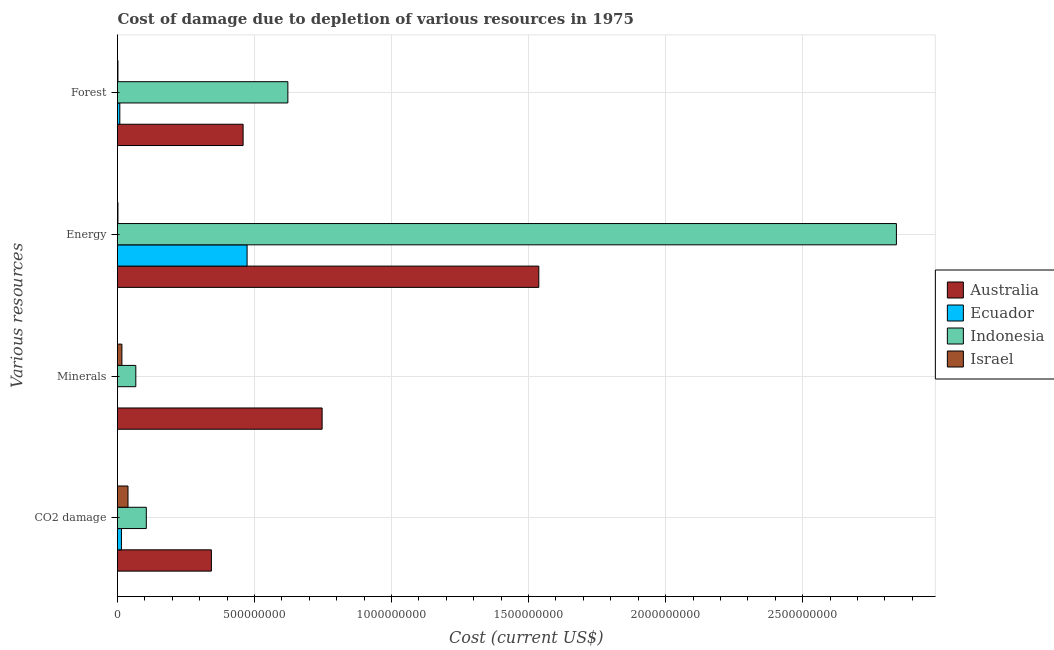How many groups of bars are there?
Give a very brief answer. 4. Are the number of bars per tick equal to the number of legend labels?
Your answer should be compact. Yes. What is the label of the 1st group of bars from the top?
Provide a succinct answer. Forest. What is the cost of damage due to depletion of forests in Australia?
Ensure brevity in your answer.  4.58e+08. Across all countries, what is the maximum cost of damage due to depletion of energy?
Your answer should be compact. 2.84e+09. Across all countries, what is the minimum cost of damage due to depletion of forests?
Make the answer very short. 1.56e+06. In which country was the cost of damage due to depletion of energy minimum?
Keep it short and to the point. Israel. What is the total cost of damage due to depletion of minerals in the graph?
Offer a terse response. 8.29e+08. What is the difference between the cost of damage due to depletion of energy in Indonesia and that in Ecuador?
Give a very brief answer. 2.37e+09. What is the difference between the cost of damage due to depletion of forests in Israel and the cost of damage due to depletion of coal in Ecuador?
Keep it short and to the point. -1.28e+07. What is the average cost of damage due to depletion of minerals per country?
Provide a short and direct response. 2.07e+08. What is the difference between the cost of damage due to depletion of minerals and cost of damage due to depletion of forests in Israel?
Your answer should be very brief. 1.45e+07. What is the ratio of the cost of damage due to depletion of energy in Ecuador to that in Indonesia?
Provide a short and direct response. 0.17. Is the difference between the cost of damage due to depletion of forests in Israel and Indonesia greater than the difference between the cost of damage due to depletion of minerals in Israel and Indonesia?
Provide a succinct answer. No. What is the difference between the highest and the second highest cost of damage due to depletion of minerals?
Your response must be concise. 6.80e+08. What is the difference between the highest and the lowest cost of damage due to depletion of energy?
Make the answer very short. 2.84e+09. What does the 2nd bar from the bottom in Minerals represents?
Give a very brief answer. Ecuador. Is it the case that in every country, the sum of the cost of damage due to depletion of coal and cost of damage due to depletion of minerals is greater than the cost of damage due to depletion of energy?
Your response must be concise. No. How many bars are there?
Make the answer very short. 16. How many countries are there in the graph?
Provide a succinct answer. 4. Where does the legend appear in the graph?
Your answer should be compact. Center right. What is the title of the graph?
Your answer should be compact. Cost of damage due to depletion of various resources in 1975 . Does "Canada" appear as one of the legend labels in the graph?
Make the answer very short. No. What is the label or title of the X-axis?
Your answer should be compact. Cost (current US$). What is the label or title of the Y-axis?
Ensure brevity in your answer.  Various resources. What is the Cost (current US$) in Australia in CO2 damage?
Give a very brief answer. 3.43e+08. What is the Cost (current US$) in Ecuador in CO2 damage?
Make the answer very short. 1.43e+07. What is the Cost (current US$) in Indonesia in CO2 damage?
Make the answer very short. 1.05e+08. What is the Cost (current US$) in Israel in CO2 damage?
Offer a very short reply. 3.83e+07. What is the Cost (current US$) in Australia in Minerals?
Ensure brevity in your answer.  7.47e+08. What is the Cost (current US$) in Ecuador in Minerals?
Offer a very short reply. 4.07e+04. What is the Cost (current US$) of Indonesia in Minerals?
Your response must be concise. 6.68e+07. What is the Cost (current US$) of Israel in Minerals?
Offer a very short reply. 1.60e+07. What is the Cost (current US$) in Australia in Energy?
Keep it short and to the point. 1.54e+09. What is the Cost (current US$) in Ecuador in Energy?
Ensure brevity in your answer.  4.73e+08. What is the Cost (current US$) in Indonesia in Energy?
Provide a succinct answer. 2.84e+09. What is the Cost (current US$) in Israel in Energy?
Keep it short and to the point. 1.55e+06. What is the Cost (current US$) of Australia in Forest?
Your answer should be compact. 4.58e+08. What is the Cost (current US$) in Ecuador in Forest?
Offer a terse response. 8.42e+06. What is the Cost (current US$) of Indonesia in Forest?
Keep it short and to the point. 6.22e+08. What is the Cost (current US$) in Israel in Forest?
Give a very brief answer. 1.56e+06. Across all Various resources, what is the maximum Cost (current US$) in Australia?
Give a very brief answer. 1.54e+09. Across all Various resources, what is the maximum Cost (current US$) in Ecuador?
Provide a succinct answer. 4.73e+08. Across all Various resources, what is the maximum Cost (current US$) in Indonesia?
Your response must be concise. 2.84e+09. Across all Various resources, what is the maximum Cost (current US$) in Israel?
Your answer should be compact. 3.83e+07. Across all Various resources, what is the minimum Cost (current US$) of Australia?
Your answer should be compact. 3.43e+08. Across all Various resources, what is the minimum Cost (current US$) of Ecuador?
Make the answer very short. 4.07e+04. Across all Various resources, what is the minimum Cost (current US$) in Indonesia?
Provide a succinct answer. 6.68e+07. Across all Various resources, what is the minimum Cost (current US$) in Israel?
Your response must be concise. 1.55e+06. What is the total Cost (current US$) in Australia in the graph?
Your answer should be compact. 3.08e+09. What is the total Cost (current US$) of Ecuador in the graph?
Offer a very short reply. 4.96e+08. What is the total Cost (current US$) in Indonesia in the graph?
Make the answer very short. 3.64e+09. What is the total Cost (current US$) in Israel in the graph?
Provide a short and direct response. 5.74e+07. What is the difference between the Cost (current US$) in Australia in CO2 damage and that in Minerals?
Provide a succinct answer. -4.04e+08. What is the difference between the Cost (current US$) in Ecuador in CO2 damage and that in Minerals?
Give a very brief answer. 1.43e+07. What is the difference between the Cost (current US$) in Indonesia in CO2 damage and that in Minerals?
Provide a short and direct response. 3.83e+07. What is the difference between the Cost (current US$) of Israel in CO2 damage and that in Minerals?
Keep it short and to the point. 2.22e+07. What is the difference between the Cost (current US$) in Australia in CO2 damage and that in Energy?
Give a very brief answer. -1.19e+09. What is the difference between the Cost (current US$) of Ecuador in CO2 damage and that in Energy?
Your answer should be compact. -4.59e+08. What is the difference between the Cost (current US$) in Indonesia in CO2 damage and that in Energy?
Provide a short and direct response. -2.74e+09. What is the difference between the Cost (current US$) in Israel in CO2 damage and that in Energy?
Offer a terse response. 3.67e+07. What is the difference between the Cost (current US$) of Australia in CO2 damage and that in Forest?
Your answer should be very brief. -1.16e+08. What is the difference between the Cost (current US$) of Ecuador in CO2 damage and that in Forest?
Keep it short and to the point. 5.93e+06. What is the difference between the Cost (current US$) of Indonesia in CO2 damage and that in Forest?
Ensure brevity in your answer.  -5.16e+08. What is the difference between the Cost (current US$) of Israel in CO2 damage and that in Forest?
Give a very brief answer. 3.67e+07. What is the difference between the Cost (current US$) of Australia in Minerals and that in Energy?
Ensure brevity in your answer.  -7.91e+08. What is the difference between the Cost (current US$) in Ecuador in Minerals and that in Energy?
Offer a very short reply. -4.73e+08. What is the difference between the Cost (current US$) in Indonesia in Minerals and that in Energy?
Ensure brevity in your answer.  -2.78e+09. What is the difference between the Cost (current US$) of Israel in Minerals and that in Energy?
Ensure brevity in your answer.  1.45e+07. What is the difference between the Cost (current US$) of Australia in Minerals and that in Forest?
Ensure brevity in your answer.  2.88e+08. What is the difference between the Cost (current US$) in Ecuador in Minerals and that in Forest?
Your response must be concise. -8.38e+06. What is the difference between the Cost (current US$) in Indonesia in Minerals and that in Forest?
Make the answer very short. -5.55e+08. What is the difference between the Cost (current US$) of Israel in Minerals and that in Forest?
Your answer should be very brief. 1.45e+07. What is the difference between the Cost (current US$) in Australia in Energy and that in Forest?
Provide a short and direct response. 1.08e+09. What is the difference between the Cost (current US$) of Ecuador in Energy and that in Forest?
Keep it short and to the point. 4.64e+08. What is the difference between the Cost (current US$) of Indonesia in Energy and that in Forest?
Give a very brief answer. 2.22e+09. What is the difference between the Cost (current US$) in Israel in Energy and that in Forest?
Your response must be concise. -1.17e+04. What is the difference between the Cost (current US$) of Australia in CO2 damage and the Cost (current US$) of Ecuador in Minerals?
Your answer should be very brief. 3.43e+08. What is the difference between the Cost (current US$) in Australia in CO2 damage and the Cost (current US$) in Indonesia in Minerals?
Your response must be concise. 2.76e+08. What is the difference between the Cost (current US$) in Australia in CO2 damage and the Cost (current US$) in Israel in Minerals?
Your answer should be very brief. 3.27e+08. What is the difference between the Cost (current US$) of Ecuador in CO2 damage and the Cost (current US$) of Indonesia in Minerals?
Your answer should be compact. -5.24e+07. What is the difference between the Cost (current US$) of Ecuador in CO2 damage and the Cost (current US$) of Israel in Minerals?
Provide a short and direct response. -1.70e+06. What is the difference between the Cost (current US$) in Indonesia in CO2 damage and the Cost (current US$) in Israel in Minerals?
Ensure brevity in your answer.  8.91e+07. What is the difference between the Cost (current US$) in Australia in CO2 damage and the Cost (current US$) in Ecuador in Energy?
Give a very brief answer. -1.30e+08. What is the difference between the Cost (current US$) in Australia in CO2 damage and the Cost (current US$) in Indonesia in Energy?
Keep it short and to the point. -2.50e+09. What is the difference between the Cost (current US$) of Australia in CO2 damage and the Cost (current US$) of Israel in Energy?
Provide a short and direct response. 3.41e+08. What is the difference between the Cost (current US$) of Ecuador in CO2 damage and the Cost (current US$) of Indonesia in Energy?
Give a very brief answer. -2.83e+09. What is the difference between the Cost (current US$) of Ecuador in CO2 damage and the Cost (current US$) of Israel in Energy?
Give a very brief answer. 1.28e+07. What is the difference between the Cost (current US$) of Indonesia in CO2 damage and the Cost (current US$) of Israel in Energy?
Keep it short and to the point. 1.04e+08. What is the difference between the Cost (current US$) in Australia in CO2 damage and the Cost (current US$) in Ecuador in Forest?
Offer a very short reply. 3.34e+08. What is the difference between the Cost (current US$) in Australia in CO2 damage and the Cost (current US$) in Indonesia in Forest?
Your answer should be very brief. -2.79e+08. What is the difference between the Cost (current US$) in Australia in CO2 damage and the Cost (current US$) in Israel in Forest?
Keep it short and to the point. 3.41e+08. What is the difference between the Cost (current US$) in Ecuador in CO2 damage and the Cost (current US$) in Indonesia in Forest?
Provide a short and direct response. -6.07e+08. What is the difference between the Cost (current US$) in Ecuador in CO2 damage and the Cost (current US$) in Israel in Forest?
Give a very brief answer. 1.28e+07. What is the difference between the Cost (current US$) in Indonesia in CO2 damage and the Cost (current US$) in Israel in Forest?
Your response must be concise. 1.04e+08. What is the difference between the Cost (current US$) of Australia in Minerals and the Cost (current US$) of Ecuador in Energy?
Make the answer very short. 2.74e+08. What is the difference between the Cost (current US$) in Australia in Minerals and the Cost (current US$) in Indonesia in Energy?
Keep it short and to the point. -2.10e+09. What is the difference between the Cost (current US$) of Australia in Minerals and the Cost (current US$) of Israel in Energy?
Your answer should be very brief. 7.45e+08. What is the difference between the Cost (current US$) of Ecuador in Minerals and the Cost (current US$) of Indonesia in Energy?
Provide a short and direct response. -2.84e+09. What is the difference between the Cost (current US$) in Ecuador in Minerals and the Cost (current US$) in Israel in Energy?
Ensure brevity in your answer.  -1.51e+06. What is the difference between the Cost (current US$) of Indonesia in Minerals and the Cost (current US$) of Israel in Energy?
Ensure brevity in your answer.  6.52e+07. What is the difference between the Cost (current US$) of Australia in Minerals and the Cost (current US$) of Ecuador in Forest?
Offer a very short reply. 7.38e+08. What is the difference between the Cost (current US$) in Australia in Minerals and the Cost (current US$) in Indonesia in Forest?
Provide a short and direct response. 1.25e+08. What is the difference between the Cost (current US$) of Australia in Minerals and the Cost (current US$) of Israel in Forest?
Make the answer very short. 7.45e+08. What is the difference between the Cost (current US$) of Ecuador in Minerals and the Cost (current US$) of Indonesia in Forest?
Offer a terse response. -6.22e+08. What is the difference between the Cost (current US$) of Ecuador in Minerals and the Cost (current US$) of Israel in Forest?
Make the answer very short. -1.52e+06. What is the difference between the Cost (current US$) of Indonesia in Minerals and the Cost (current US$) of Israel in Forest?
Your response must be concise. 6.52e+07. What is the difference between the Cost (current US$) of Australia in Energy and the Cost (current US$) of Ecuador in Forest?
Keep it short and to the point. 1.53e+09. What is the difference between the Cost (current US$) of Australia in Energy and the Cost (current US$) of Indonesia in Forest?
Your answer should be compact. 9.16e+08. What is the difference between the Cost (current US$) of Australia in Energy and the Cost (current US$) of Israel in Forest?
Keep it short and to the point. 1.54e+09. What is the difference between the Cost (current US$) of Ecuador in Energy and the Cost (current US$) of Indonesia in Forest?
Provide a short and direct response. -1.49e+08. What is the difference between the Cost (current US$) in Ecuador in Energy and the Cost (current US$) in Israel in Forest?
Your answer should be compact. 4.71e+08. What is the difference between the Cost (current US$) of Indonesia in Energy and the Cost (current US$) of Israel in Forest?
Your response must be concise. 2.84e+09. What is the average Cost (current US$) of Australia per Various resources?
Keep it short and to the point. 7.71e+08. What is the average Cost (current US$) in Ecuador per Various resources?
Keep it short and to the point. 1.24e+08. What is the average Cost (current US$) of Indonesia per Various resources?
Keep it short and to the point. 9.09e+08. What is the average Cost (current US$) in Israel per Various resources?
Offer a terse response. 1.44e+07. What is the difference between the Cost (current US$) of Australia and Cost (current US$) of Ecuador in CO2 damage?
Ensure brevity in your answer.  3.28e+08. What is the difference between the Cost (current US$) in Australia and Cost (current US$) in Indonesia in CO2 damage?
Your answer should be very brief. 2.37e+08. What is the difference between the Cost (current US$) of Australia and Cost (current US$) of Israel in CO2 damage?
Provide a succinct answer. 3.04e+08. What is the difference between the Cost (current US$) of Ecuador and Cost (current US$) of Indonesia in CO2 damage?
Make the answer very short. -9.08e+07. What is the difference between the Cost (current US$) in Ecuador and Cost (current US$) in Israel in CO2 damage?
Provide a succinct answer. -2.39e+07. What is the difference between the Cost (current US$) in Indonesia and Cost (current US$) in Israel in CO2 damage?
Keep it short and to the point. 6.68e+07. What is the difference between the Cost (current US$) in Australia and Cost (current US$) in Ecuador in Minerals?
Keep it short and to the point. 7.47e+08. What is the difference between the Cost (current US$) in Australia and Cost (current US$) in Indonesia in Minerals?
Provide a succinct answer. 6.80e+08. What is the difference between the Cost (current US$) of Australia and Cost (current US$) of Israel in Minerals?
Your answer should be compact. 7.31e+08. What is the difference between the Cost (current US$) of Ecuador and Cost (current US$) of Indonesia in Minerals?
Your response must be concise. -6.67e+07. What is the difference between the Cost (current US$) of Ecuador and Cost (current US$) of Israel in Minerals?
Provide a short and direct response. -1.60e+07. What is the difference between the Cost (current US$) in Indonesia and Cost (current US$) in Israel in Minerals?
Your response must be concise. 5.08e+07. What is the difference between the Cost (current US$) of Australia and Cost (current US$) of Ecuador in Energy?
Offer a terse response. 1.06e+09. What is the difference between the Cost (current US$) in Australia and Cost (current US$) in Indonesia in Energy?
Make the answer very short. -1.30e+09. What is the difference between the Cost (current US$) in Australia and Cost (current US$) in Israel in Energy?
Offer a very short reply. 1.54e+09. What is the difference between the Cost (current US$) in Ecuador and Cost (current US$) in Indonesia in Energy?
Give a very brief answer. -2.37e+09. What is the difference between the Cost (current US$) of Ecuador and Cost (current US$) of Israel in Energy?
Provide a succinct answer. 4.71e+08. What is the difference between the Cost (current US$) of Indonesia and Cost (current US$) of Israel in Energy?
Ensure brevity in your answer.  2.84e+09. What is the difference between the Cost (current US$) of Australia and Cost (current US$) of Ecuador in Forest?
Your response must be concise. 4.50e+08. What is the difference between the Cost (current US$) in Australia and Cost (current US$) in Indonesia in Forest?
Ensure brevity in your answer.  -1.63e+08. What is the difference between the Cost (current US$) in Australia and Cost (current US$) in Israel in Forest?
Your answer should be very brief. 4.57e+08. What is the difference between the Cost (current US$) in Ecuador and Cost (current US$) in Indonesia in Forest?
Keep it short and to the point. -6.13e+08. What is the difference between the Cost (current US$) in Ecuador and Cost (current US$) in Israel in Forest?
Your response must be concise. 6.85e+06. What is the difference between the Cost (current US$) of Indonesia and Cost (current US$) of Israel in Forest?
Your response must be concise. 6.20e+08. What is the ratio of the Cost (current US$) in Australia in CO2 damage to that in Minerals?
Offer a very short reply. 0.46. What is the ratio of the Cost (current US$) in Ecuador in CO2 damage to that in Minerals?
Offer a terse response. 352.48. What is the ratio of the Cost (current US$) of Indonesia in CO2 damage to that in Minerals?
Keep it short and to the point. 1.57. What is the ratio of the Cost (current US$) in Israel in CO2 damage to that in Minerals?
Provide a short and direct response. 2.39. What is the ratio of the Cost (current US$) in Australia in CO2 damage to that in Energy?
Make the answer very short. 0.22. What is the ratio of the Cost (current US$) of Ecuador in CO2 damage to that in Energy?
Your response must be concise. 0.03. What is the ratio of the Cost (current US$) of Indonesia in CO2 damage to that in Energy?
Ensure brevity in your answer.  0.04. What is the ratio of the Cost (current US$) of Israel in CO2 damage to that in Energy?
Your answer should be very brief. 24.66. What is the ratio of the Cost (current US$) of Australia in CO2 damage to that in Forest?
Provide a succinct answer. 0.75. What is the ratio of the Cost (current US$) in Ecuador in CO2 damage to that in Forest?
Give a very brief answer. 1.7. What is the ratio of the Cost (current US$) of Indonesia in CO2 damage to that in Forest?
Offer a very short reply. 0.17. What is the ratio of the Cost (current US$) in Israel in CO2 damage to that in Forest?
Provide a short and direct response. 24.48. What is the ratio of the Cost (current US$) of Australia in Minerals to that in Energy?
Your answer should be compact. 0.49. What is the ratio of the Cost (current US$) in Indonesia in Minerals to that in Energy?
Give a very brief answer. 0.02. What is the ratio of the Cost (current US$) of Israel in Minerals to that in Energy?
Give a very brief answer. 10.34. What is the ratio of the Cost (current US$) in Australia in Minerals to that in Forest?
Your answer should be compact. 1.63. What is the ratio of the Cost (current US$) in Ecuador in Minerals to that in Forest?
Your answer should be compact. 0. What is the ratio of the Cost (current US$) in Indonesia in Minerals to that in Forest?
Keep it short and to the point. 0.11. What is the ratio of the Cost (current US$) in Israel in Minerals to that in Forest?
Ensure brevity in your answer.  10.26. What is the ratio of the Cost (current US$) of Australia in Energy to that in Forest?
Offer a terse response. 3.35. What is the ratio of the Cost (current US$) in Ecuador in Energy to that in Forest?
Ensure brevity in your answer.  56.19. What is the ratio of the Cost (current US$) of Indonesia in Energy to that in Forest?
Offer a very short reply. 4.57. What is the difference between the highest and the second highest Cost (current US$) of Australia?
Offer a very short reply. 7.91e+08. What is the difference between the highest and the second highest Cost (current US$) of Ecuador?
Your answer should be compact. 4.59e+08. What is the difference between the highest and the second highest Cost (current US$) in Indonesia?
Your response must be concise. 2.22e+09. What is the difference between the highest and the second highest Cost (current US$) in Israel?
Your answer should be very brief. 2.22e+07. What is the difference between the highest and the lowest Cost (current US$) of Australia?
Offer a very short reply. 1.19e+09. What is the difference between the highest and the lowest Cost (current US$) of Ecuador?
Make the answer very short. 4.73e+08. What is the difference between the highest and the lowest Cost (current US$) of Indonesia?
Make the answer very short. 2.78e+09. What is the difference between the highest and the lowest Cost (current US$) of Israel?
Make the answer very short. 3.67e+07. 